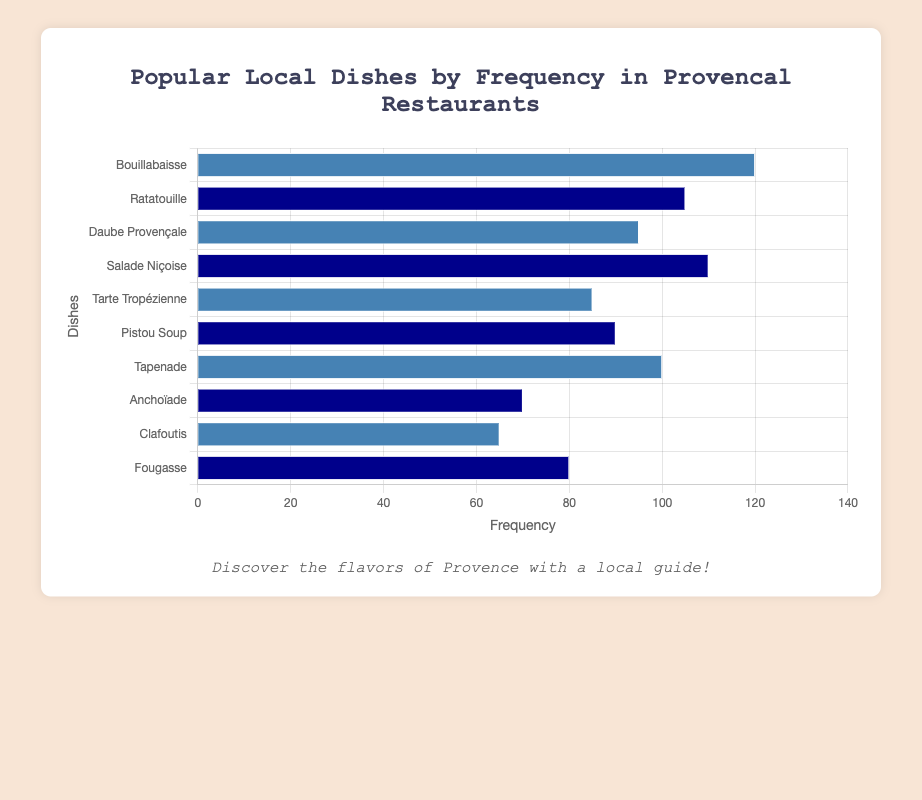Which dish is the most frequently offered in Provençal restaurants? The dish with the highest frequency bar in the chart is Bouillabaisse.
Answer: Bouillabaisse How many dishes have a frequency higher than 100? Identify the bars with a frequency exceeding 100, which are Bouillabaisse (120), Ratatouille (105), and Salade Niçoise (110). Count these dishes.
Answer: 3 What is the total frequency of Daube Provençale and Tarte Tropézienne combined? Add the frequencies of Daube Provençale (95) and Tarte Tropézienne (85).
Answer: 180 Which dish has the least frequency and what is its value? The dish with the shortest bar in the chart is Clafoutis, with a frequency value of 65.
Answer: Clafoutis, 65 Is the frequency of Salade Niçoise greater than that of Tapenade? Compare the frequency of Salade Niçoise (110) to that of Tapenade (100).
Answer: Yes What are the average frequencies of the blue-colored dishes? Calculate the average by adding the frequencies of Bouillabaisse (120), Daube Provençale (95), Tarte Tropézienne (85), Tapenade (100), and Clafoutis (65) and dividing by 5.
Answer: 93 Which two dishes have the closest frequency values, and what are they? Compare the frequencies of all dishes to find the smallest difference: Tarte Tropézienne (85) and Pistou Soup (90).
Answer: Tarte Tropézienne and Pistou Soup How much greater is the frequency of Bouillabaisse compared to Anchoïade? Subtract the frequency of Anchoïade (70) from Bouillabaisse (120).
Answer: 50 Which dish has the second highest frequency? The dish with the second tallest bar after Bouillabaisse (120) is Salade Niçoise (110).
Answer: Salade Niçoise How many dishes have a frequency lower than 90? Count the bars with frequencies under 90, which are Anchoïade (70), Clafoutis (65), and Fougasse (80).
Answer: 3 